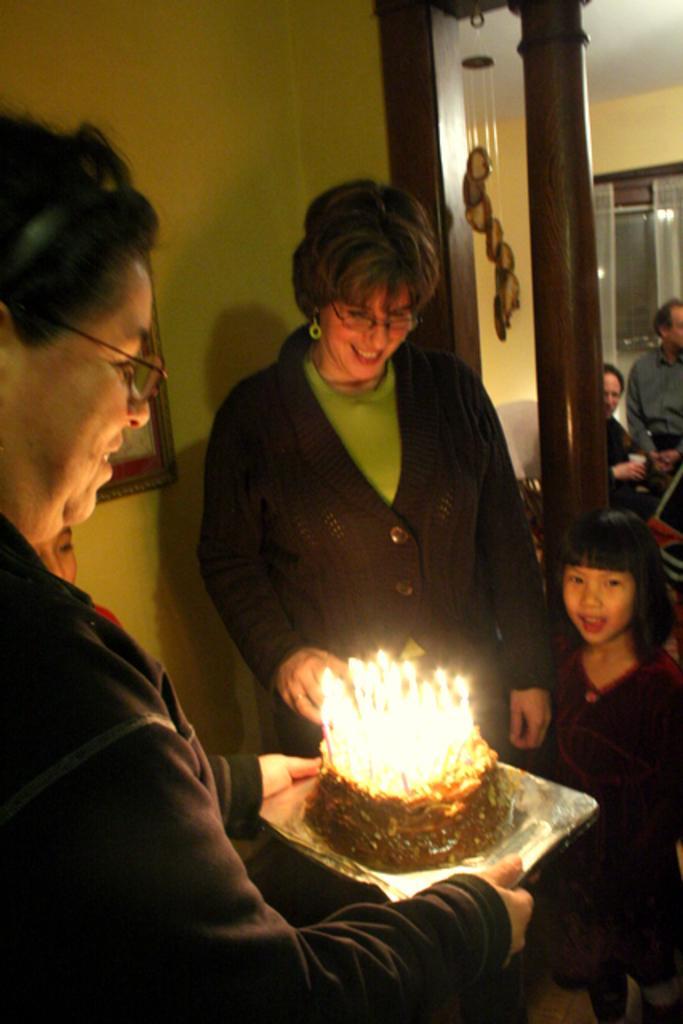How would you summarize this image in a sentence or two? These people are standing and this person holding plate with cake and candles. We can see frame on a wall. Background we can see people,window and curtains. 